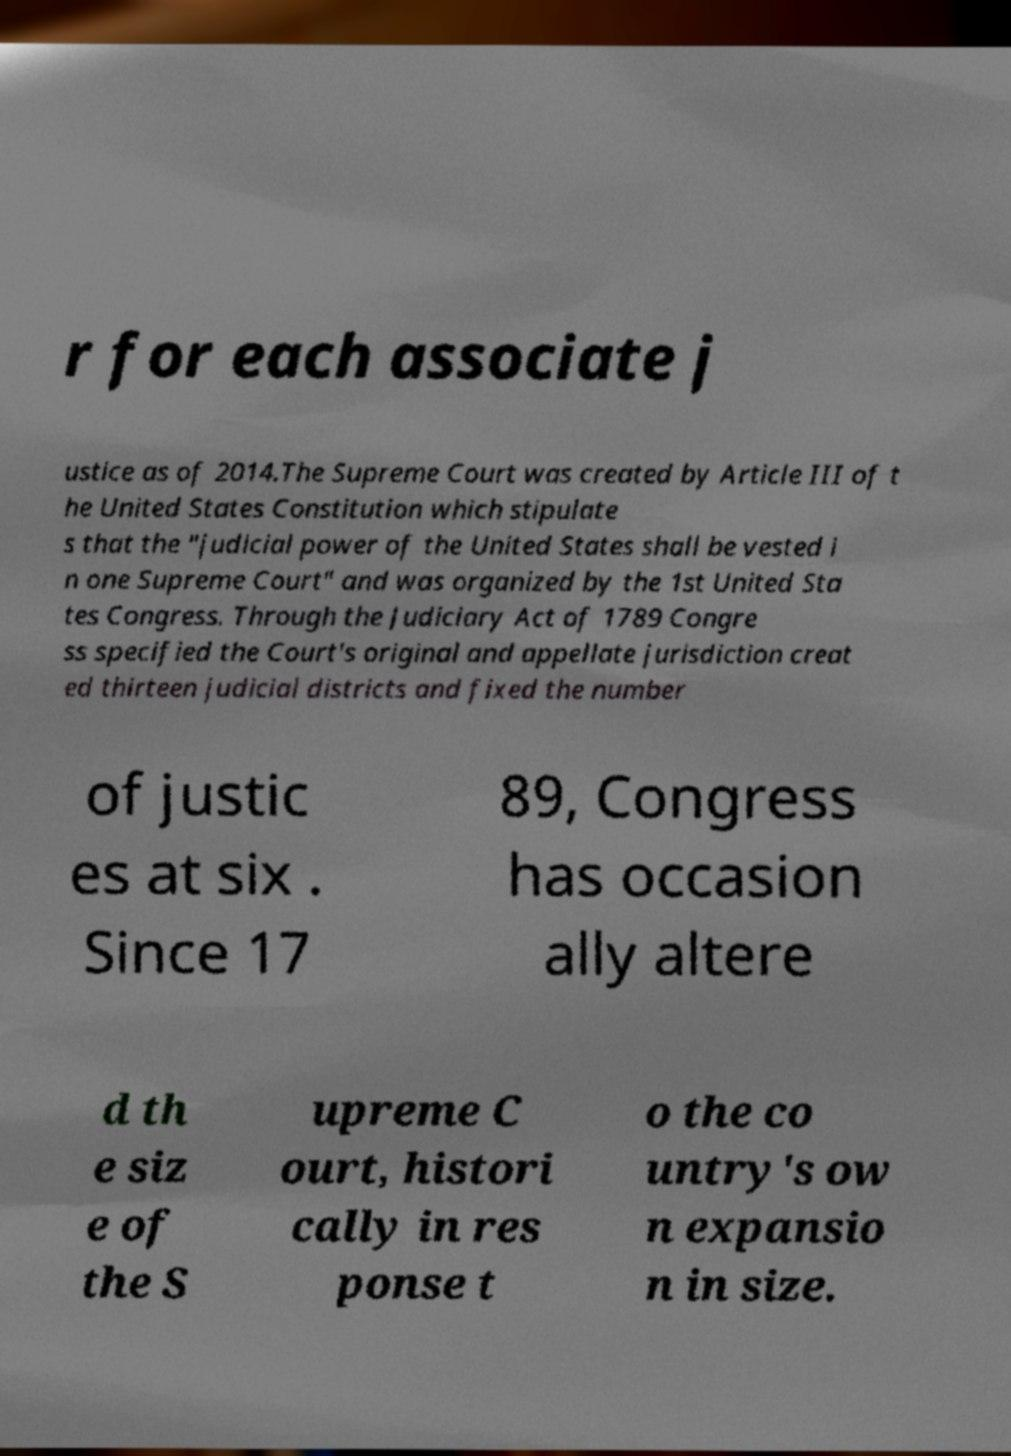Can you read and provide the text displayed in the image?This photo seems to have some interesting text. Can you extract and type it out for me? r for each associate j ustice as of 2014.The Supreme Court was created by Article III of t he United States Constitution which stipulate s that the "judicial power of the United States shall be vested i n one Supreme Court" and was organized by the 1st United Sta tes Congress. Through the Judiciary Act of 1789 Congre ss specified the Court's original and appellate jurisdiction creat ed thirteen judicial districts and fixed the number of justic es at six . Since 17 89, Congress has occasion ally altere d th e siz e of the S upreme C ourt, histori cally in res ponse t o the co untry's ow n expansio n in size. 